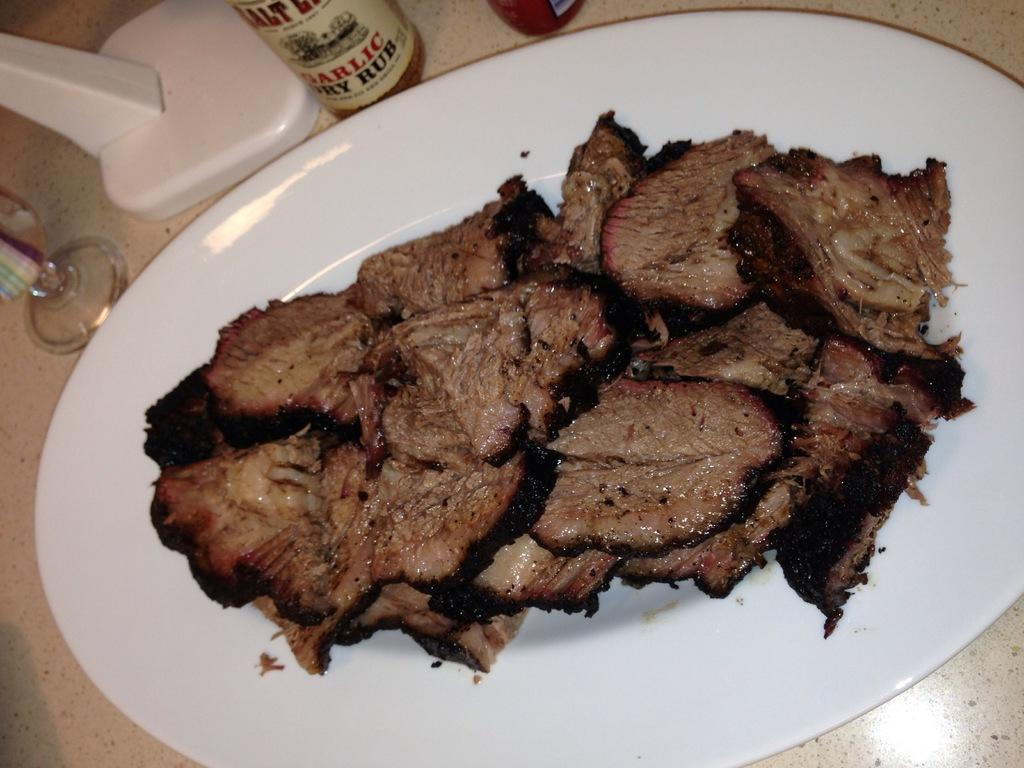<image>
Summarize the visual content of the image. The garlic dry rub is next to the steak on the plate 